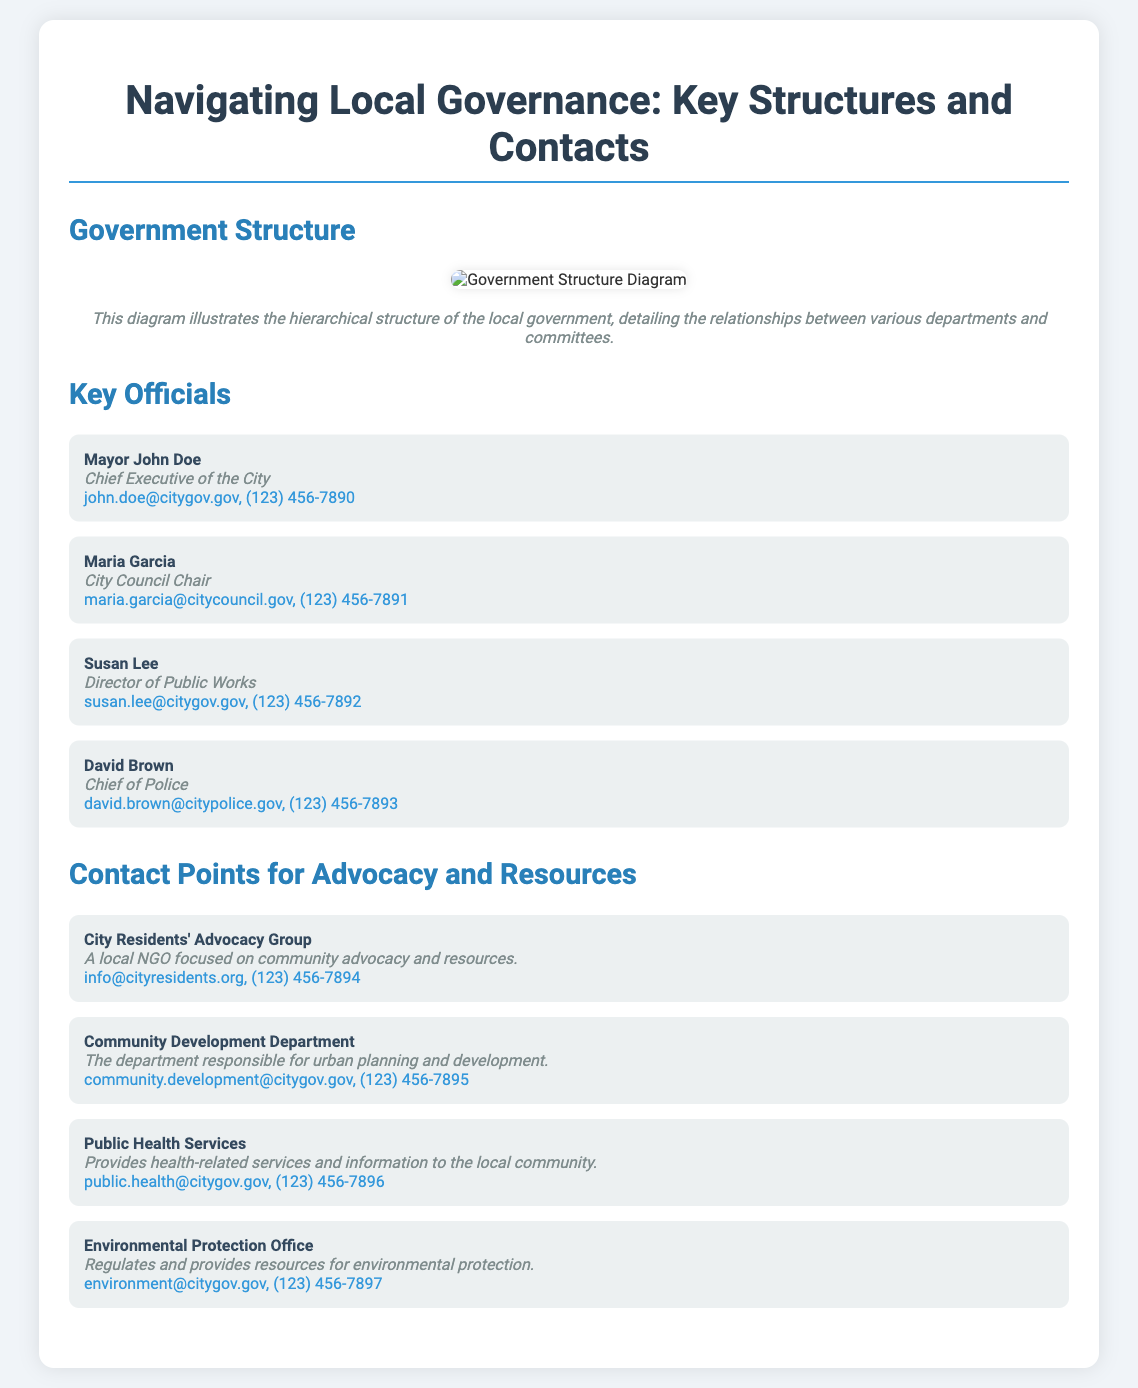What is the name of the mayor? The name of the mayor is listed in the Key Officials section as Mayor John Doe.
Answer: John Doe Who is the City Council Chair? The document states that Maria Garcia holds the position of City Council Chair.
Answer: Maria Garcia How many key officials are listed? The number of key officials mentioned in the document is four.
Answer: Four What is the contact number for Public Health Services? The contact number can be found in the Contact Points section, associated with Public Health Services.
Answer: (123) 456-7896 What organization is focused on community advocacy? The City Residents' Advocacy Group is identified as a local NGO focused on community advocacy.
Answer: City Residents' Advocacy Group Which department is responsible for urban planning? The Community Development Department is mentioned as responsible for urban planning and development.
Answer: Community Development Department What is the position of Susan Lee? The document specifies that Susan Lee is the Director of Public Works.
Answer: Director of Public Works What is the contact for the Environmental Protection Office? The contact information for the Environmental Protection Office is provided in the Contact Points section.
Answer: environment@citygov.gov, (123) 456-7897 What type of document is this? The document is a poster designed to navigate local governance structures and contacts.
Answer: Poster 